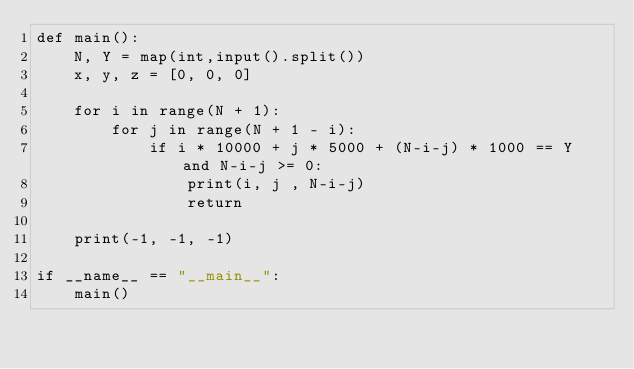<code> <loc_0><loc_0><loc_500><loc_500><_Python_>def main():
    N, Y = map(int,input().split())
    x, y, z = [0, 0, 0]
    
    for i in range(N + 1):
        for j in range(N + 1 - i):
            if i * 10000 + j * 5000 + (N-i-j) * 1000 == Y and N-i-j >= 0:
                print(i, j , N-i-j)
                return
    
    print(-1, -1, -1)

if __name__ == "__main__":
    main()
</code> 